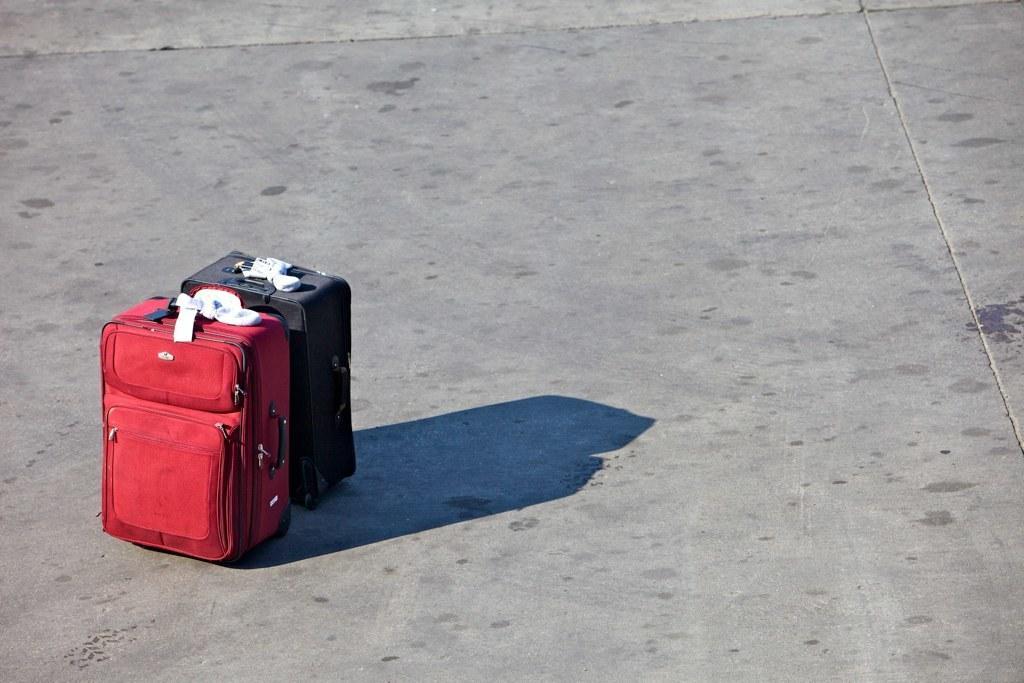Can you describe this image briefly? In this picture two luggage kept on the floor 